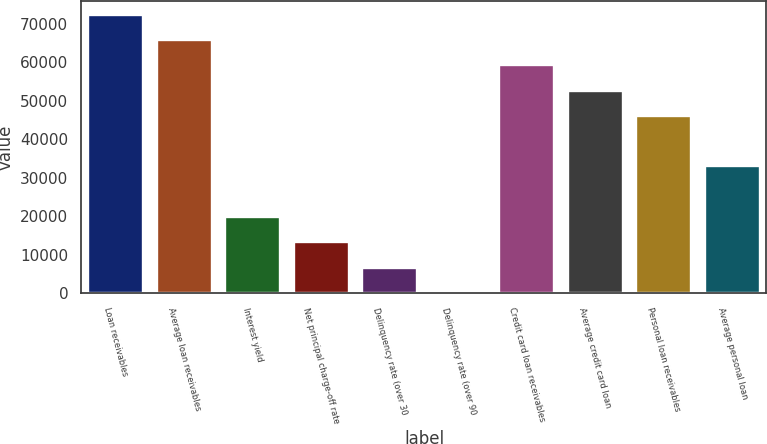Convert chart to OTSL. <chart><loc_0><loc_0><loc_500><loc_500><bar_chart><fcel>Loan receivables<fcel>Average loan receivables<fcel>Interest yield<fcel>Net principal charge-off rate<fcel>Delinquency rate (over 30<fcel>Delinquency rate (over 90<fcel>Credit card loan receivables<fcel>Average credit card loan<fcel>Personal loan receivables<fcel>Average personal loan<nl><fcel>72348<fcel>65771<fcel>19731.8<fcel>13154.8<fcel>6577.79<fcel>0.77<fcel>59193.9<fcel>52616.9<fcel>46039.9<fcel>32885.9<nl></chart> 